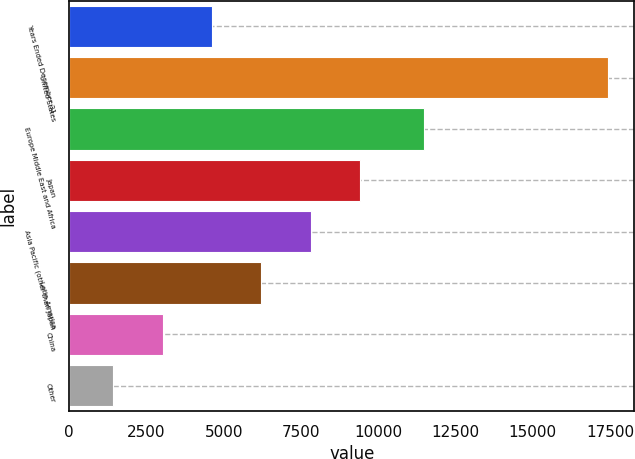<chart> <loc_0><loc_0><loc_500><loc_500><bar_chart><fcel>Years Ended December 31<fcel>United States<fcel>Europe Middle East and Africa<fcel>Japan<fcel>Asia Pacific (other than Japan<fcel>Latin America<fcel>China<fcel>Other<nl><fcel>4622.4<fcel>17424<fcel>11478<fcel>9423<fcel>7822.8<fcel>6222.6<fcel>3022.2<fcel>1422<nl></chart> 